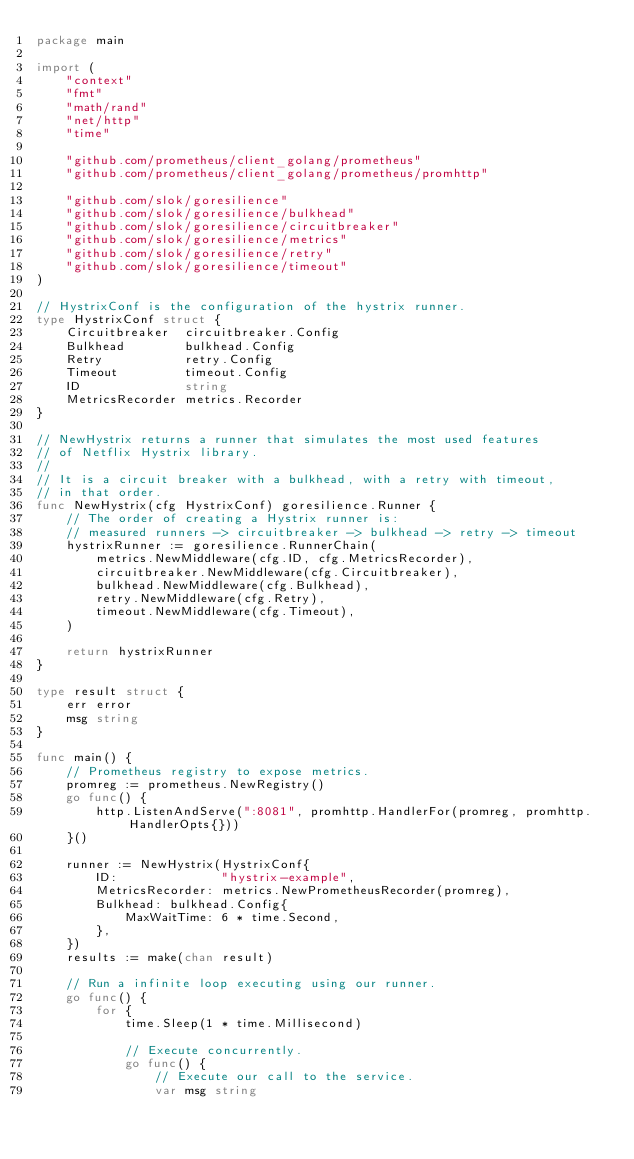Convert code to text. <code><loc_0><loc_0><loc_500><loc_500><_Go_>package main

import (
	"context"
	"fmt"
	"math/rand"
	"net/http"
	"time"

	"github.com/prometheus/client_golang/prometheus"
	"github.com/prometheus/client_golang/prometheus/promhttp"

	"github.com/slok/goresilience"
	"github.com/slok/goresilience/bulkhead"
	"github.com/slok/goresilience/circuitbreaker"
	"github.com/slok/goresilience/metrics"
	"github.com/slok/goresilience/retry"
	"github.com/slok/goresilience/timeout"
)

// HystrixConf is the configuration of the hystrix runner.
type HystrixConf struct {
	Circuitbreaker  circuitbreaker.Config
	Bulkhead        bulkhead.Config
	Retry           retry.Config
	Timeout         timeout.Config
	ID              string
	MetricsRecorder metrics.Recorder
}

// NewHystrix returns a runner that simulates the most used features
// of Netflix Hystrix library.
//
// It is a circuit breaker with a bulkhead, with a retry with timeout,
// in that order.
func NewHystrix(cfg HystrixConf) goresilience.Runner {
	// The order of creating a Hystrix runner is:
	// measured runners -> circuitbreaker -> bulkhead -> retry -> timeout
	hystrixRunner := goresilience.RunnerChain(
		metrics.NewMiddleware(cfg.ID, cfg.MetricsRecorder),
		circuitbreaker.NewMiddleware(cfg.Circuitbreaker),
		bulkhead.NewMiddleware(cfg.Bulkhead),
		retry.NewMiddleware(cfg.Retry),
		timeout.NewMiddleware(cfg.Timeout),
	)

	return hystrixRunner
}

type result struct {
	err error
	msg string
}

func main() {
	// Prometheus registry to expose metrics.
	promreg := prometheus.NewRegistry()
	go func() {
		http.ListenAndServe(":8081", promhttp.HandlerFor(promreg, promhttp.HandlerOpts{}))
	}()

	runner := NewHystrix(HystrixConf{
		ID:              "hystrix-example",
		MetricsRecorder: metrics.NewPrometheusRecorder(promreg),
		Bulkhead: bulkhead.Config{
			MaxWaitTime: 6 * time.Second,
		},
	})
	results := make(chan result)

	// Run a infinite loop executing using our runner.
	go func() {
		for {
			time.Sleep(1 * time.Millisecond)

			// Execute concurrently.
			go func() {
				// Execute our call to the service.
				var msg string</code> 